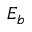Convert formula to latex. <formula><loc_0><loc_0><loc_500><loc_500>E _ { b }</formula> 